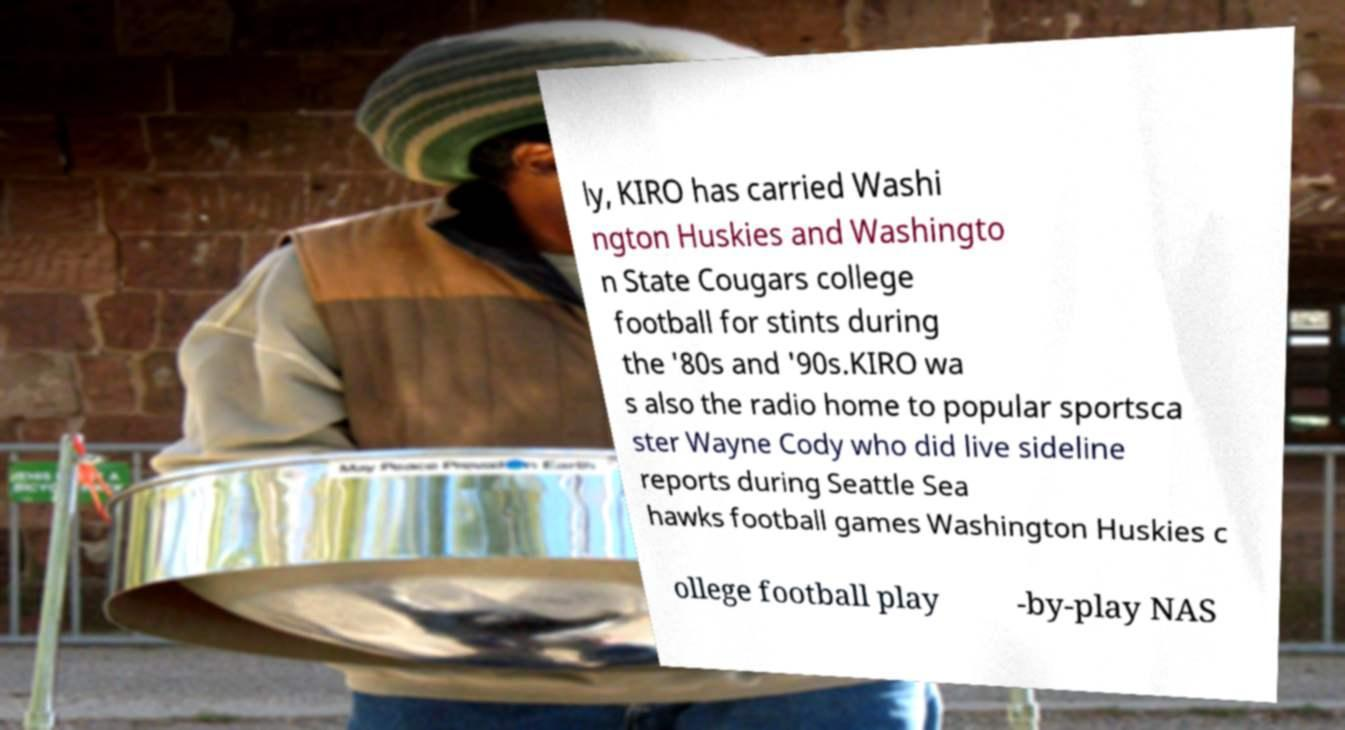Could you extract and type out the text from this image? ly, KIRO has carried Washi ngton Huskies and Washingto n State Cougars college football for stints during the '80s and '90s.KIRO wa s also the radio home to popular sportsca ster Wayne Cody who did live sideline reports during Seattle Sea hawks football games Washington Huskies c ollege football play -by-play NAS 